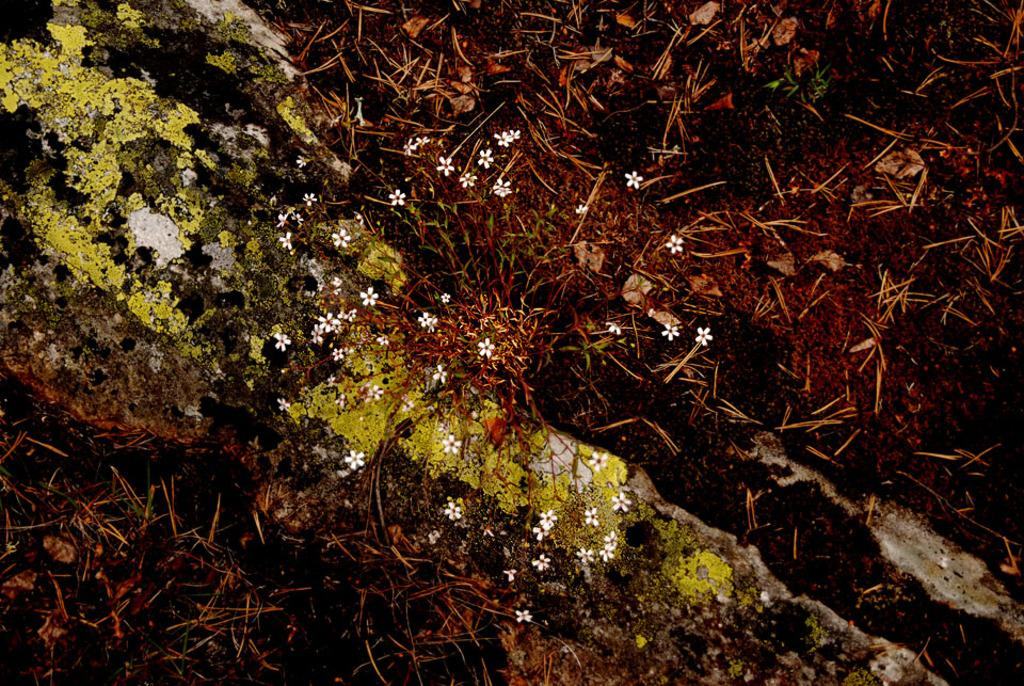Where was the image most likely taken? The image was likely taken outside. What is the main subject of the image? There are white color flowers in the center of the image. What can be observed about the stems of the flowers? There are dry stems visible in the image. Are there any other objects present in the image besides the flowers? Yes, there are other objects present in the image. What type of committee is meeting in the image? There is no committee present in the image; it features white color flowers and dry stems. Can you see any frogs in the image? There are no frogs present in the image. 